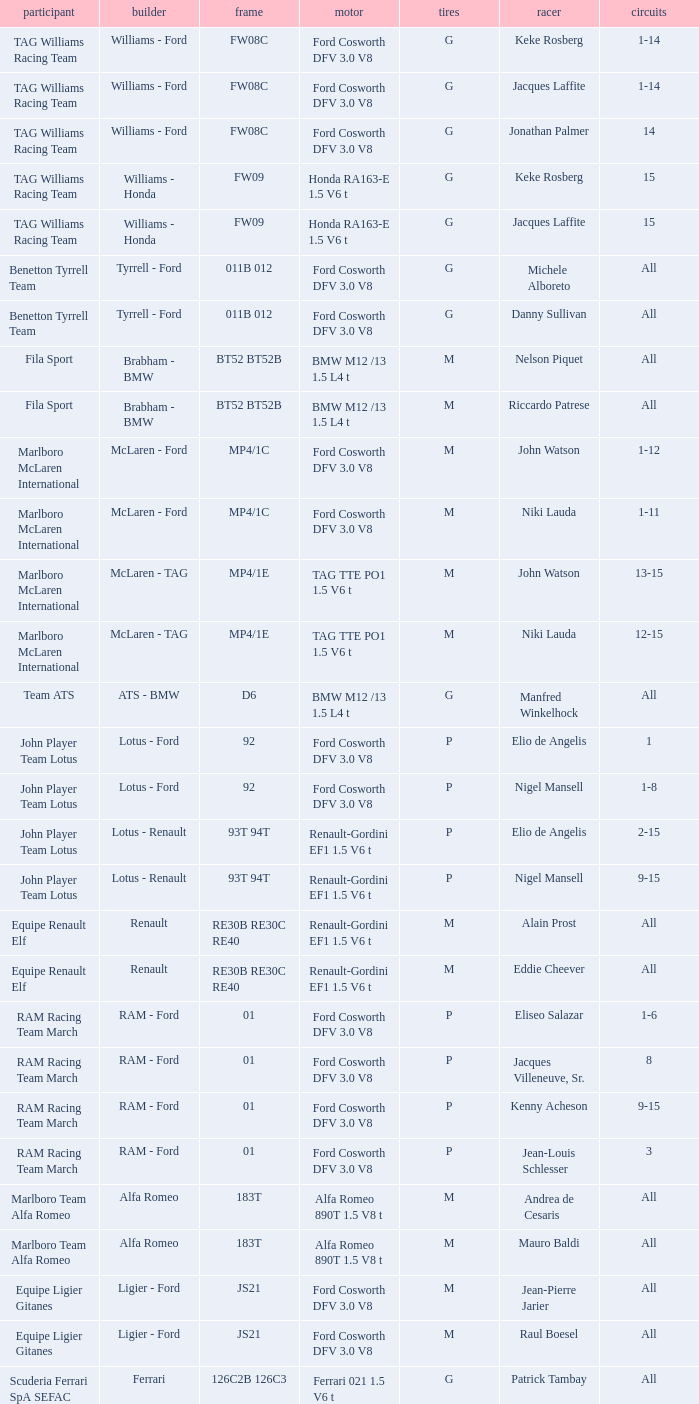Who is driver of the d6 chassis? Manfred Winkelhock. 